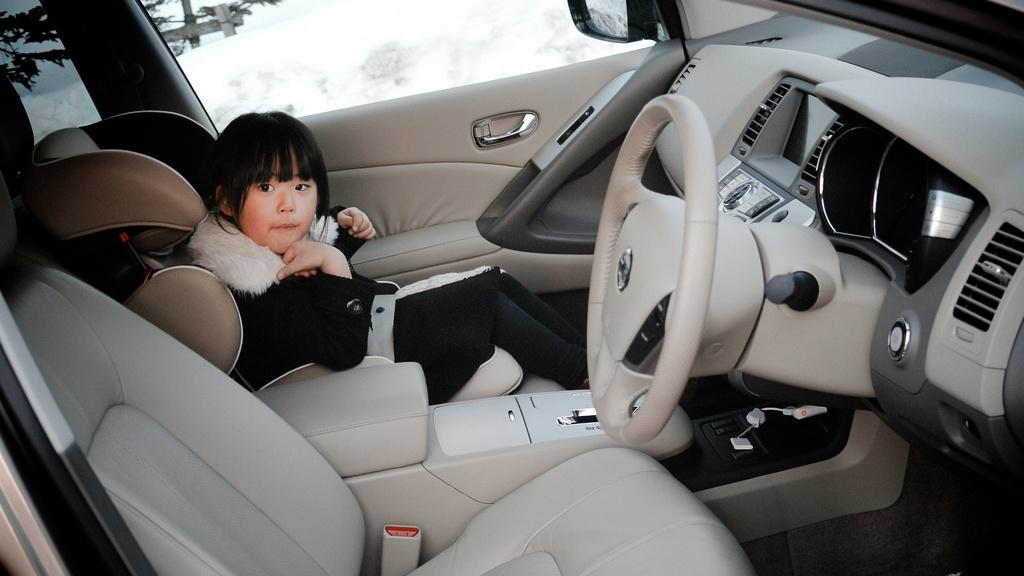What is inside the car in the image? There is a child in the car. What can be seen outside the car? There is a tree outside the car. What is the weather like in the image? There is snow visible in the image, indicating a cold or wintry setting. What object is made of wood in the image? There is a wooden stand in the image. What type of hand is visible on the canvas in the image? There is no canvas or hand present in the image. What meal is being prepared in the image? There is no meal preparation visible in the image. 